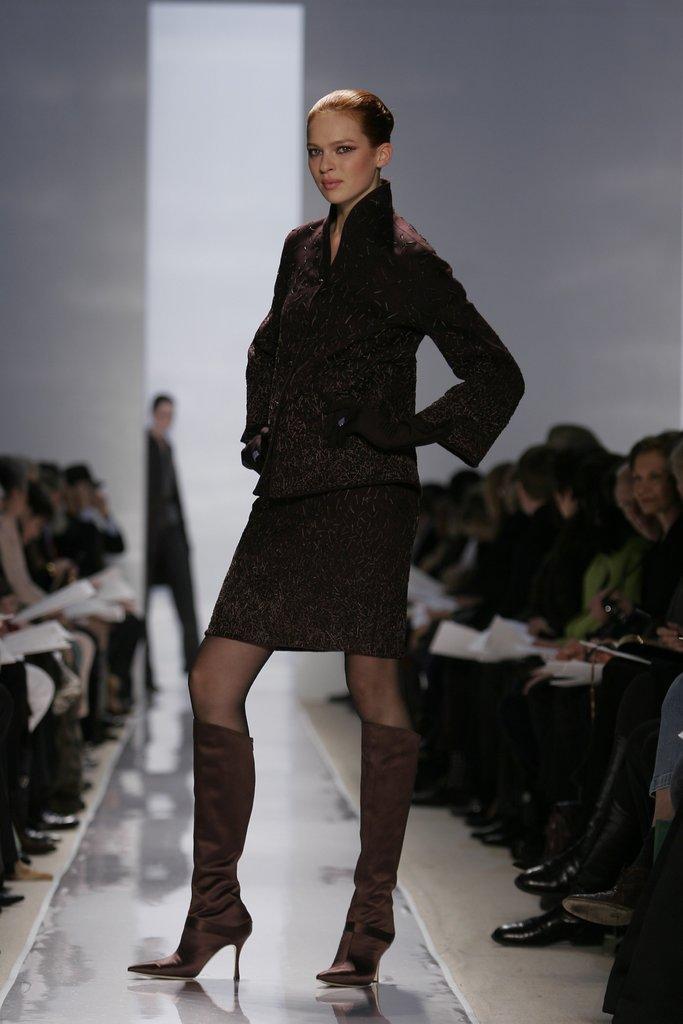Can you describe this image briefly? In this image we can see one woman in black dress standing on the floor, one man walking, some people sitting on the right and left side of the image. There are some people holding objects, it looks like a wall in the background and the background is blurred. 